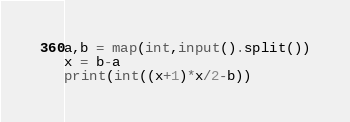<code> <loc_0><loc_0><loc_500><loc_500><_Python_>a,b = map(int,input().split())
x = b-a
print(int((x+1)*x/2-b))</code> 